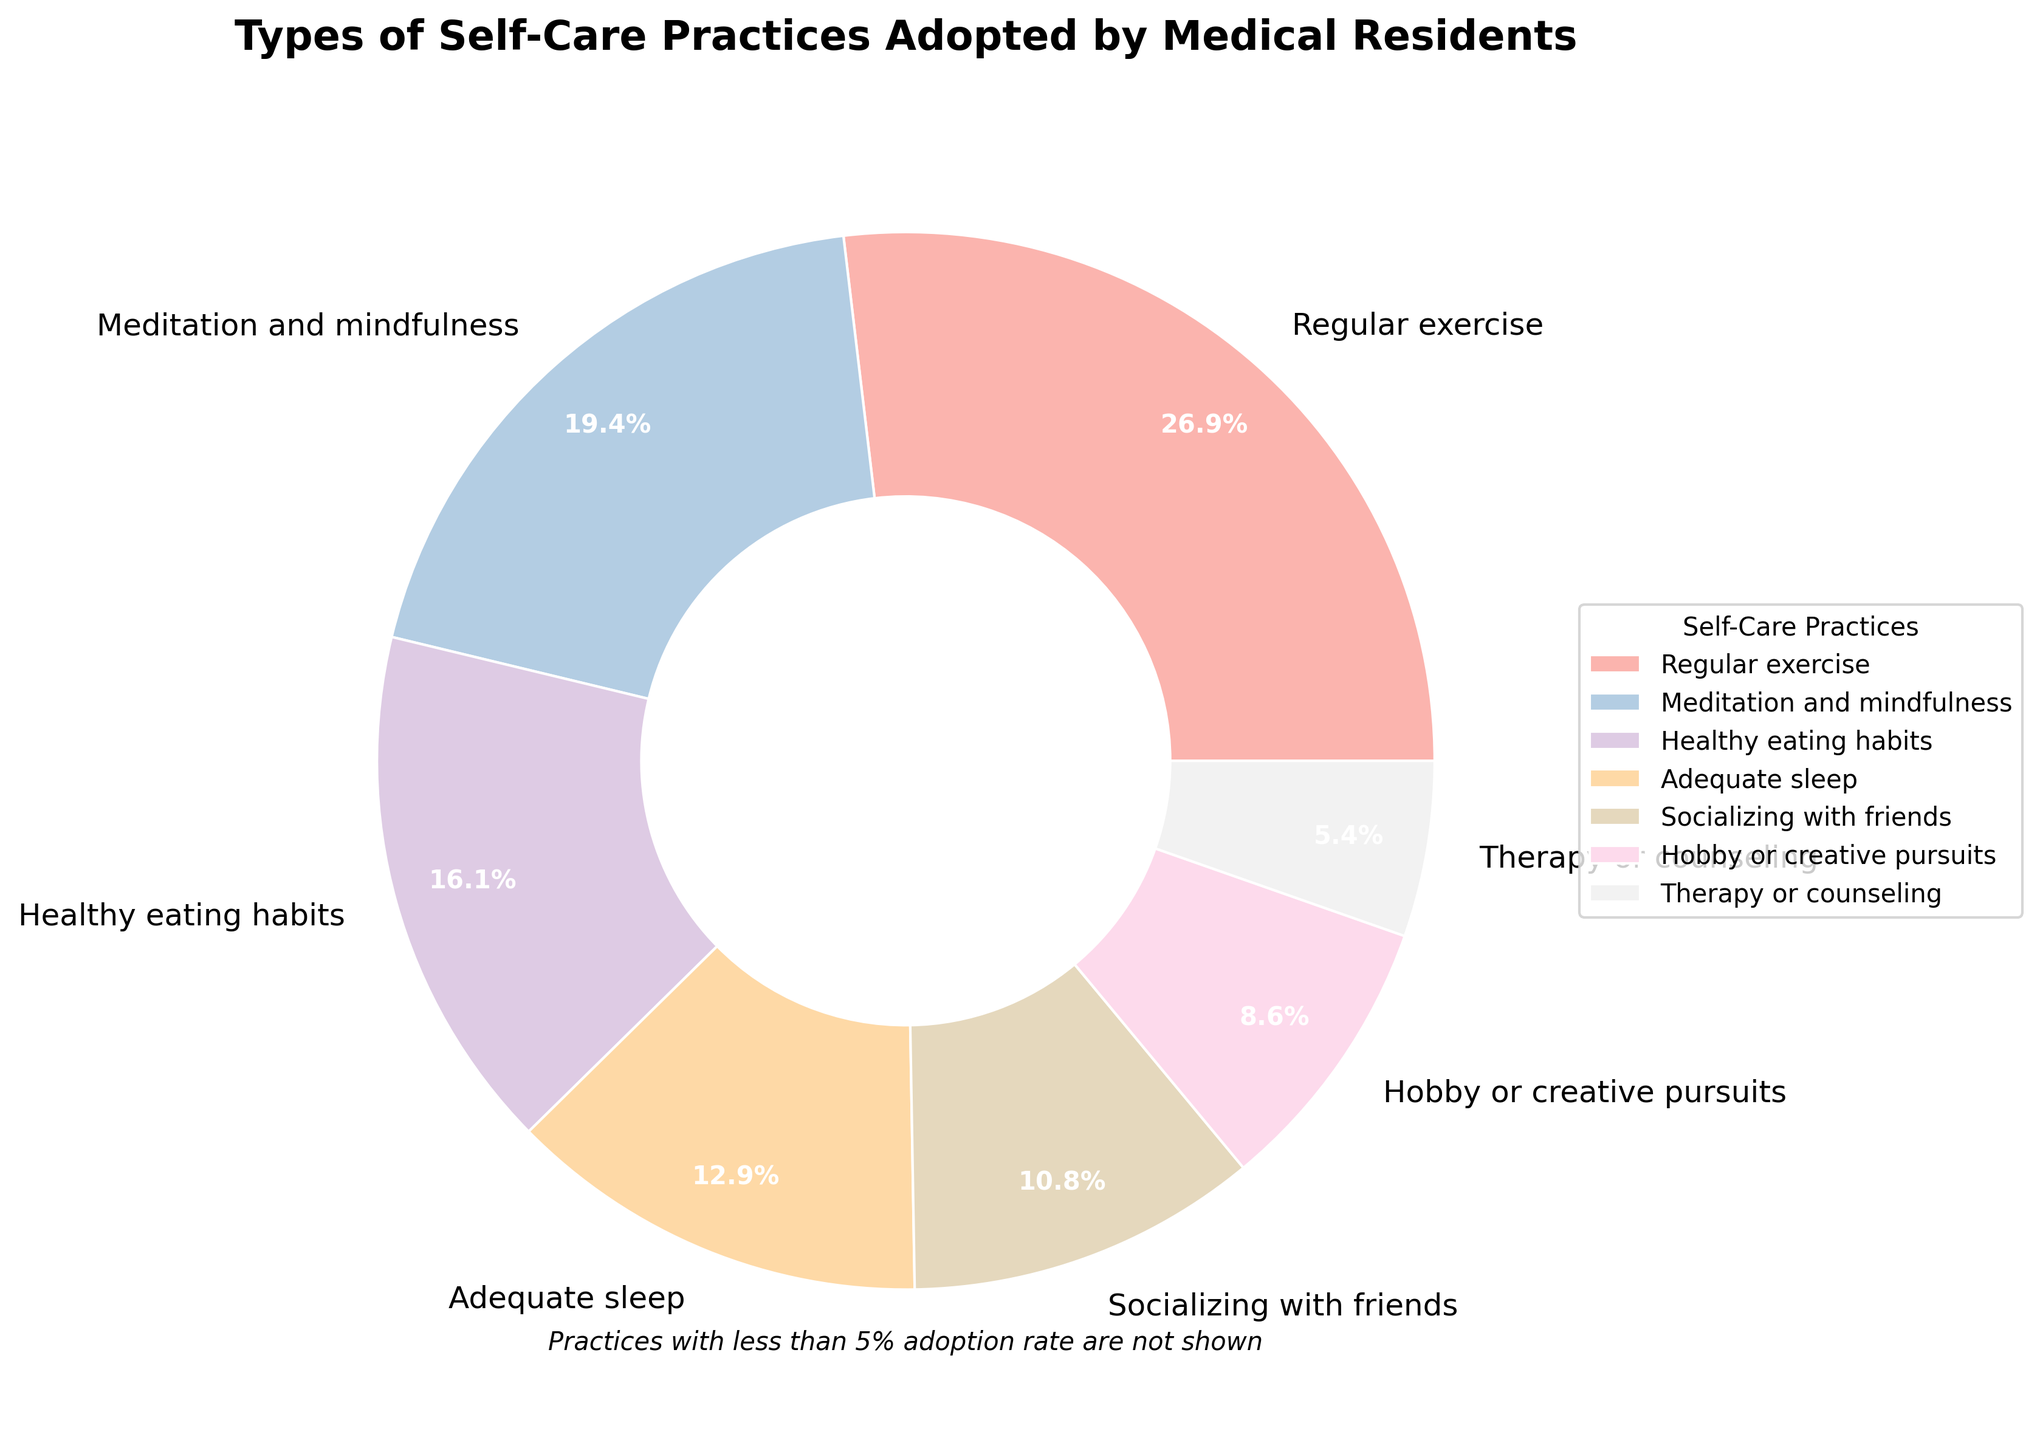What percentage of residents practice activities related to mental health (Meditation and mindfulness, Therapy or counseling)? Add the percentages for Meditation and mindfulness (18%) and Therapy or counseling (5%). 18% + 5% = 23%
Answer: 23% Which self-care practice is the most popular among medical residents? Refer to the percentages in the pie chart. The segment labeled with the highest percentage is Regular exercise at 25%.
Answer: Regular exercise How does the percentage of residents engaging in adequate sleep compare to those engaging in healthy eating habits? Compare the percentages of Adequate sleep (12%) and Healthy eating habits (15%). 15% is greater than 12%.
Answer: Healthy eating habits have a higher percentage What is the sum of percentages of residents who practice Regular exercise and Socializing with friends? Add the percentages for Regular exercise (25%) and Socializing with friends (10%). 25% + 10% = 35%
Answer: 35% Which self-care practices have the same percentage of residents adopting them? Identify segments with the same percentage. Yoga, Reading for pleasure, Listening to music, and Outdoor activities all have 2%.
Answer: Yoga, Reading for pleasure, Listening to music, and Outdoor activities Between Healthy eating habits and Hobby or creative pursuits, which one is more popular among medical residents and by how much? Find the difference between percentages of Healthy eating habits (15%) and Hobby or creative pursuits (8%). 15% - 8% = 7%
Answer: Healthy eating habits by 7% How much more popular is Regular exercise compared to Meditation and mindfulness? Subtract the percentage of Meditation and mindfulness (18%) from the percentage of Regular exercise (25%). 25% - 18% = 7%
Answer: Regular exercise by 7% What percentage of residents practice Time management techniques, Yoga, and Adequate sleep combined? Add the percentages for Time management techniques (3%), Yoga (2%), and Adequate sleep (12%). 3% + 2% + 12% = 17%
Answer: 17% Which self-care practice has exactly half the percentage adoption rate of Regular exercise? Half of Regular exercise (25%) is 12.5%. Adequate sleep is closest with 12%.
Answer: Adequate sleep 